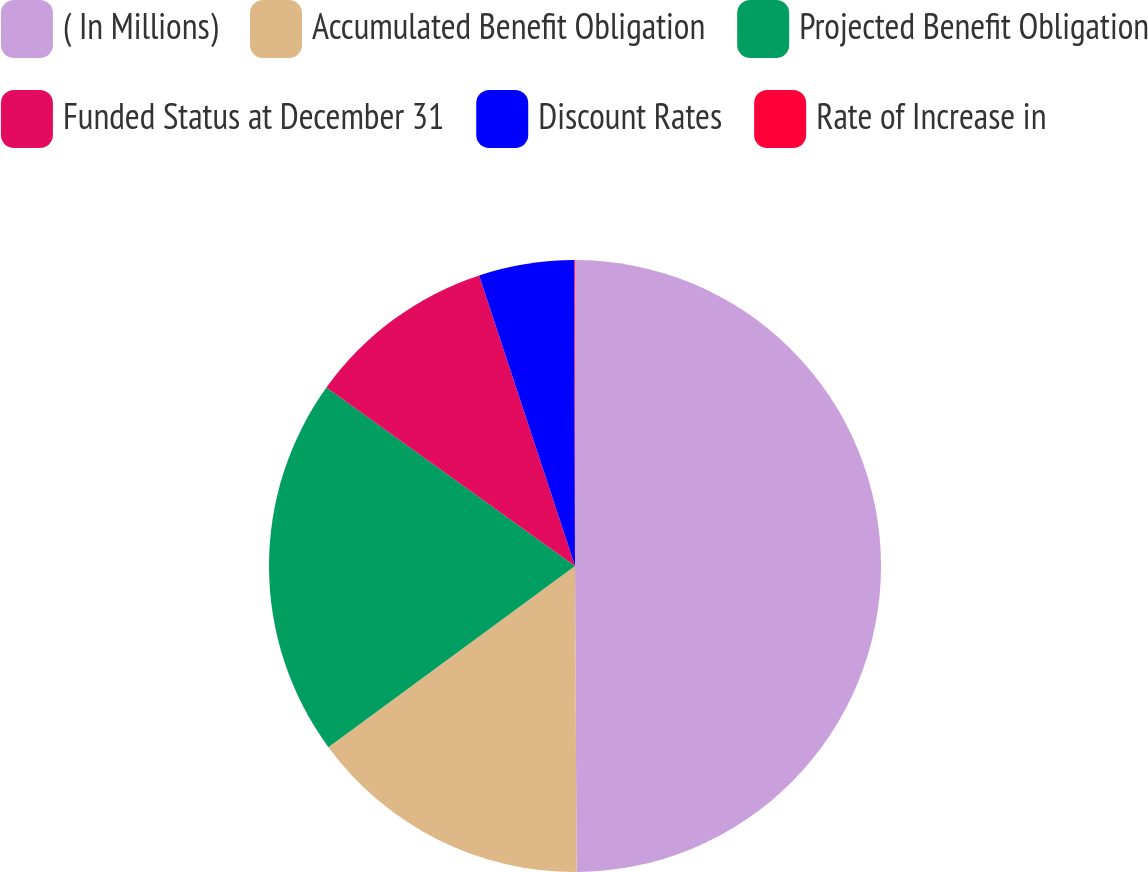<chart> <loc_0><loc_0><loc_500><loc_500><pie_chart><fcel>( In Millions)<fcel>Accumulated Benefit Obligation<fcel>Projected Benefit Obligation<fcel>Funded Status at December 31<fcel>Discount Rates<fcel>Rate of Increase in<nl><fcel>49.91%<fcel>15.0%<fcel>19.99%<fcel>10.02%<fcel>5.03%<fcel>0.04%<nl></chart> 